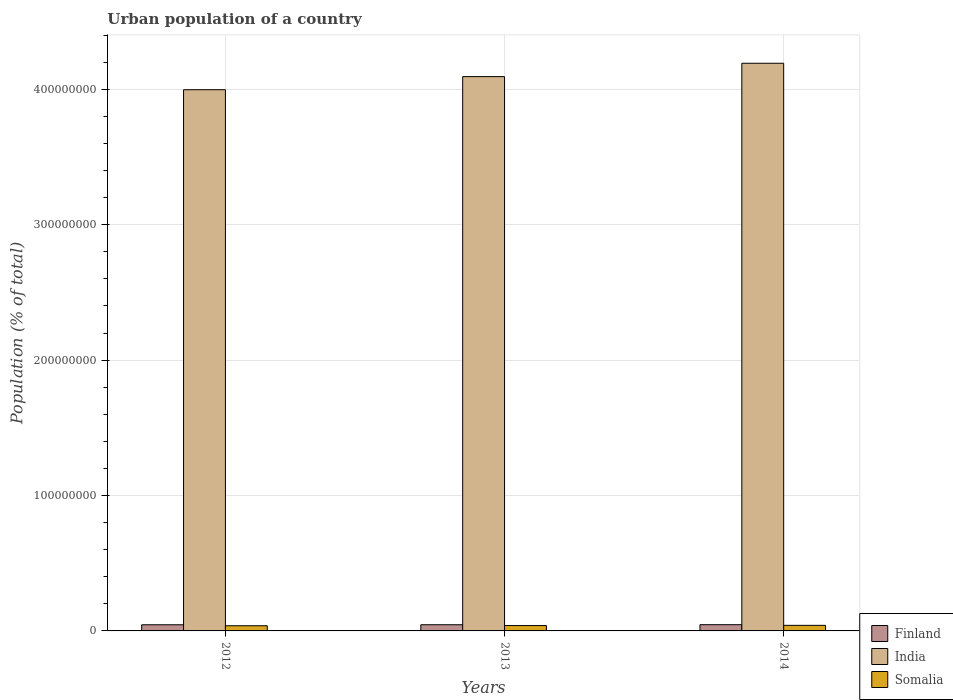How many different coloured bars are there?
Offer a very short reply. 3. Are the number of bars on each tick of the X-axis equal?
Ensure brevity in your answer.  Yes. How many bars are there on the 2nd tick from the left?
Ensure brevity in your answer.  3. How many bars are there on the 3rd tick from the right?
Your response must be concise. 3. What is the label of the 2nd group of bars from the left?
Offer a very short reply. 2013. What is the urban population in Finland in 2012?
Offer a very short reply. 4.54e+06. Across all years, what is the maximum urban population in Finland?
Provide a short and direct response. 4.59e+06. Across all years, what is the minimum urban population in Finland?
Provide a succinct answer. 4.54e+06. What is the total urban population in Finland in the graph?
Your response must be concise. 1.37e+07. What is the difference between the urban population in Somalia in 2013 and that in 2014?
Your answer should be compact. -1.45e+05. What is the difference between the urban population in Somalia in 2014 and the urban population in Finland in 2012?
Offer a very short reply. -4.28e+05. What is the average urban population in Somalia per year?
Your response must be concise. 3.97e+06. In the year 2014, what is the difference between the urban population in India and urban population in Somalia?
Provide a short and direct response. 4.15e+08. In how many years, is the urban population in Finland greater than 100000000 %?
Your response must be concise. 0. What is the ratio of the urban population in India in 2012 to that in 2014?
Your answer should be compact. 0.95. Is the urban population in Finland in 2012 less than that in 2013?
Make the answer very short. Yes. What is the difference between the highest and the second highest urban population in Somalia?
Your answer should be very brief. 1.45e+05. What is the difference between the highest and the lowest urban population in India?
Offer a very short reply. 1.95e+07. Is the sum of the urban population in India in 2012 and 2013 greater than the maximum urban population in Somalia across all years?
Offer a very short reply. Yes. What does the 3rd bar from the left in 2014 represents?
Provide a short and direct response. Somalia. What does the 1st bar from the right in 2013 represents?
Provide a succinct answer. Somalia. How many bars are there?
Offer a very short reply. 9. Are all the bars in the graph horizontal?
Your answer should be very brief. No. How many years are there in the graph?
Your answer should be compact. 3. What is the difference between two consecutive major ticks on the Y-axis?
Provide a short and direct response. 1.00e+08. Are the values on the major ticks of Y-axis written in scientific E-notation?
Ensure brevity in your answer.  No. Does the graph contain grids?
Ensure brevity in your answer.  Yes. How many legend labels are there?
Your answer should be very brief. 3. What is the title of the graph?
Your answer should be compact. Urban population of a country. What is the label or title of the X-axis?
Provide a short and direct response. Years. What is the label or title of the Y-axis?
Offer a very short reply. Population (% of total). What is the Population (% of total) of Finland in 2012?
Provide a succinct answer. 4.54e+06. What is the Population (% of total) of India in 2012?
Ensure brevity in your answer.  4.00e+08. What is the Population (% of total) in Somalia in 2012?
Your response must be concise. 3.83e+06. What is the Population (% of total) of Finland in 2013?
Offer a terse response. 4.57e+06. What is the Population (% of total) of India in 2013?
Provide a succinct answer. 4.09e+08. What is the Population (% of total) in Somalia in 2013?
Offer a terse response. 3.96e+06. What is the Population (% of total) of Finland in 2014?
Provide a succinct answer. 4.59e+06. What is the Population (% of total) of India in 2014?
Your answer should be compact. 4.19e+08. What is the Population (% of total) in Somalia in 2014?
Give a very brief answer. 4.11e+06. Across all years, what is the maximum Population (% of total) of Finland?
Keep it short and to the point. 4.59e+06. Across all years, what is the maximum Population (% of total) in India?
Provide a succinct answer. 4.19e+08. Across all years, what is the maximum Population (% of total) of Somalia?
Offer a very short reply. 4.11e+06. Across all years, what is the minimum Population (% of total) in Finland?
Make the answer very short. 4.54e+06. Across all years, what is the minimum Population (% of total) of India?
Your response must be concise. 4.00e+08. Across all years, what is the minimum Population (% of total) of Somalia?
Offer a very short reply. 3.83e+06. What is the total Population (% of total) of Finland in the graph?
Your answer should be compact. 1.37e+07. What is the total Population (% of total) of India in the graph?
Keep it short and to the point. 1.23e+09. What is the total Population (% of total) of Somalia in the graph?
Provide a short and direct response. 1.19e+07. What is the difference between the Population (% of total) of Finland in 2012 and that in 2013?
Make the answer very short. -2.82e+04. What is the difference between the Population (% of total) of India in 2012 and that in 2013?
Make the answer very short. -9.68e+06. What is the difference between the Population (% of total) in Somalia in 2012 and that in 2013?
Your response must be concise. -1.37e+05. What is the difference between the Population (% of total) of Finland in 2012 and that in 2014?
Ensure brevity in your answer.  -5.62e+04. What is the difference between the Population (% of total) in India in 2012 and that in 2014?
Keep it short and to the point. -1.95e+07. What is the difference between the Population (% of total) in Somalia in 2012 and that in 2014?
Provide a succinct answer. -2.82e+05. What is the difference between the Population (% of total) in Finland in 2013 and that in 2014?
Offer a terse response. -2.80e+04. What is the difference between the Population (% of total) in India in 2013 and that in 2014?
Your response must be concise. -9.87e+06. What is the difference between the Population (% of total) of Somalia in 2013 and that in 2014?
Give a very brief answer. -1.45e+05. What is the difference between the Population (% of total) in Finland in 2012 and the Population (% of total) in India in 2013?
Provide a succinct answer. -4.05e+08. What is the difference between the Population (% of total) of Finland in 2012 and the Population (% of total) of Somalia in 2013?
Offer a terse response. 5.73e+05. What is the difference between the Population (% of total) in India in 2012 and the Population (% of total) in Somalia in 2013?
Make the answer very short. 3.96e+08. What is the difference between the Population (% of total) in Finland in 2012 and the Population (% of total) in India in 2014?
Your response must be concise. -4.15e+08. What is the difference between the Population (% of total) in Finland in 2012 and the Population (% of total) in Somalia in 2014?
Provide a short and direct response. 4.28e+05. What is the difference between the Population (% of total) in India in 2012 and the Population (% of total) in Somalia in 2014?
Provide a succinct answer. 3.96e+08. What is the difference between the Population (% of total) of Finland in 2013 and the Population (% of total) of India in 2014?
Keep it short and to the point. -4.15e+08. What is the difference between the Population (% of total) in Finland in 2013 and the Population (% of total) in Somalia in 2014?
Give a very brief answer. 4.56e+05. What is the difference between the Population (% of total) in India in 2013 and the Population (% of total) in Somalia in 2014?
Your answer should be compact. 4.05e+08. What is the average Population (% of total) in Finland per year?
Make the answer very short. 4.57e+06. What is the average Population (% of total) of India per year?
Keep it short and to the point. 4.09e+08. What is the average Population (% of total) of Somalia per year?
Your response must be concise. 3.97e+06. In the year 2012, what is the difference between the Population (% of total) of Finland and Population (% of total) of India?
Your answer should be compact. -3.95e+08. In the year 2012, what is the difference between the Population (% of total) of Finland and Population (% of total) of Somalia?
Offer a terse response. 7.10e+05. In the year 2012, what is the difference between the Population (% of total) of India and Population (% of total) of Somalia?
Offer a very short reply. 3.96e+08. In the year 2013, what is the difference between the Population (% of total) of Finland and Population (% of total) of India?
Offer a very short reply. -4.05e+08. In the year 2013, what is the difference between the Population (% of total) of Finland and Population (% of total) of Somalia?
Your answer should be very brief. 6.01e+05. In the year 2013, what is the difference between the Population (% of total) of India and Population (% of total) of Somalia?
Offer a terse response. 4.05e+08. In the year 2014, what is the difference between the Population (% of total) of Finland and Population (% of total) of India?
Provide a short and direct response. -4.15e+08. In the year 2014, what is the difference between the Population (% of total) in Finland and Population (% of total) in Somalia?
Provide a short and direct response. 4.84e+05. In the year 2014, what is the difference between the Population (% of total) in India and Population (% of total) in Somalia?
Give a very brief answer. 4.15e+08. What is the ratio of the Population (% of total) in India in 2012 to that in 2013?
Make the answer very short. 0.98. What is the ratio of the Population (% of total) of Somalia in 2012 to that in 2013?
Your answer should be compact. 0.97. What is the ratio of the Population (% of total) in India in 2012 to that in 2014?
Your answer should be very brief. 0.95. What is the ratio of the Population (% of total) in Somalia in 2012 to that in 2014?
Ensure brevity in your answer.  0.93. What is the ratio of the Population (% of total) in Finland in 2013 to that in 2014?
Your response must be concise. 0.99. What is the ratio of the Population (% of total) of India in 2013 to that in 2014?
Your response must be concise. 0.98. What is the ratio of the Population (% of total) in Somalia in 2013 to that in 2014?
Offer a terse response. 0.96. What is the difference between the highest and the second highest Population (% of total) of Finland?
Keep it short and to the point. 2.80e+04. What is the difference between the highest and the second highest Population (% of total) in India?
Offer a very short reply. 9.87e+06. What is the difference between the highest and the second highest Population (% of total) of Somalia?
Keep it short and to the point. 1.45e+05. What is the difference between the highest and the lowest Population (% of total) of Finland?
Ensure brevity in your answer.  5.62e+04. What is the difference between the highest and the lowest Population (% of total) of India?
Keep it short and to the point. 1.95e+07. What is the difference between the highest and the lowest Population (% of total) in Somalia?
Offer a terse response. 2.82e+05. 